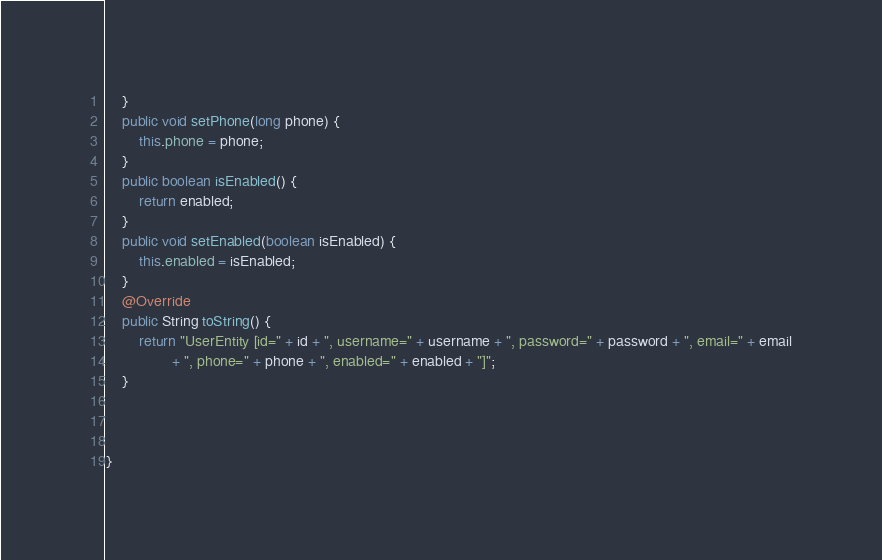Convert code to text. <code><loc_0><loc_0><loc_500><loc_500><_Java_>	}
	public void setPhone(long phone) {
		this.phone = phone;
	}
	public boolean isEnabled() {
		return enabled;
	}
	public void setEnabled(boolean isEnabled) {
		this.enabled = isEnabled;
	}
	@Override
	public String toString() {
		return "UserEntity [id=" + id + ", username=" + username + ", password=" + password + ", email=" + email
				+ ", phone=" + phone + ", enabled=" + enabled + "]";
	}
	
	
	
}
</code> 